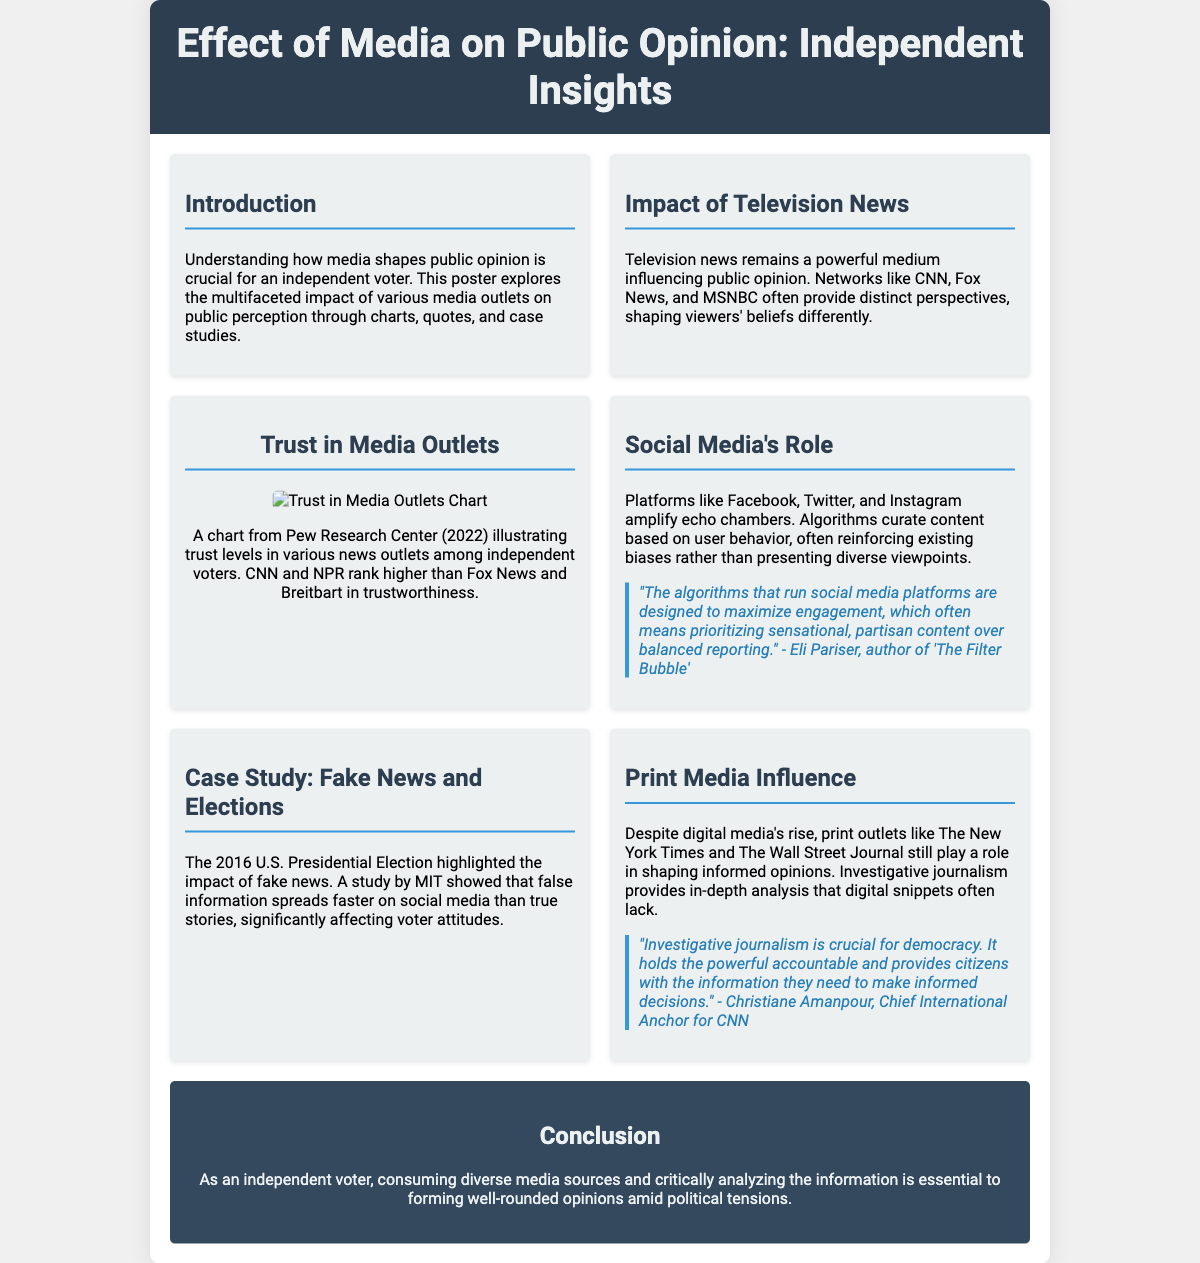What is the title of the poster? The title is stated in the header section of the document, which identifies the focus of the content.
Answer: Effect of Media on Public Opinion: Independent Insights Which media outlets are mentioned as having distinct perspectives? The document lists specific news networks in the section addressing television news.
Answer: CNN, Fox News, MSNBC What is the primary finding of the chart from Pew Research Center? The document describes the chart that indicates levels of trust in various news outlets among independent voters.
Answer: Trust levels in various news outlets Who is quoted regarding social media algorithms? The quote in the document provides insights into social media algorithms and mentions a specific author.
Answer: Eli Pariser What year did MIT conduct the study on fake news spreading? The document references a significant event relating to the spread of fake news during an election year.
Answer: 2016 What role does investigative journalism play according to a quote in the document? The document highlights the importance of a specific type of journalism, as explained in the quoted material.
Answer: Holds the powerful accountable What type of media is stated as still having an influence despite digital media's rise? The document discusses different types of media and notes one that continues to shape public opinion.
Answer: Print media How are television news outlets characterized in shaping public opinion? The document describes the role of television news specifically in influencing voters' beliefs as different.
Answer: Powerful medium What is emphasized as crucial for independent voters in the conclusion? The conclusion section of the document underscores a vital practice for independent voters amidst political tensions.
Answer: Consuming diverse media sources 